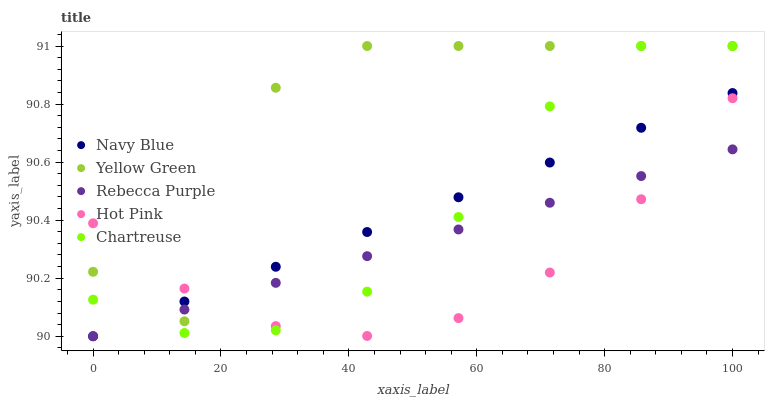Does Hot Pink have the minimum area under the curve?
Answer yes or no. Yes. Does Yellow Green have the maximum area under the curve?
Answer yes or no. Yes. Does Chartreuse have the minimum area under the curve?
Answer yes or no. No. Does Chartreuse have the maximum area under the curve?
Answer yes or no. No. Is Rebecca Purple the smoothest?
Answer yes or no. Yes. Is Yellow Green the roughest?
Answer yes or no. Yes. Is Chartreuse the smoothest?
Answer yes or no. No. Is Chartreuse the roughest?
Answer yes or no. No. Does Navy Blue have the lowest value?
Answer yes or no. Yes. Does Chartreuse have the lowest value?
Answer yes or no. No. Does Yellow Green have the highest value?
Answer yes or no. Yes. Does Hot Pink have the highest value?
Answer yes or no. No. Does Chartreuse intersect Yellow Green?
Answer yes or no. Yes. Is Chartreuse less than Yellow Green?
Answer yes or no. No. Is Chartreuse greater than Yellow Green?
Answer yes or no. No. 